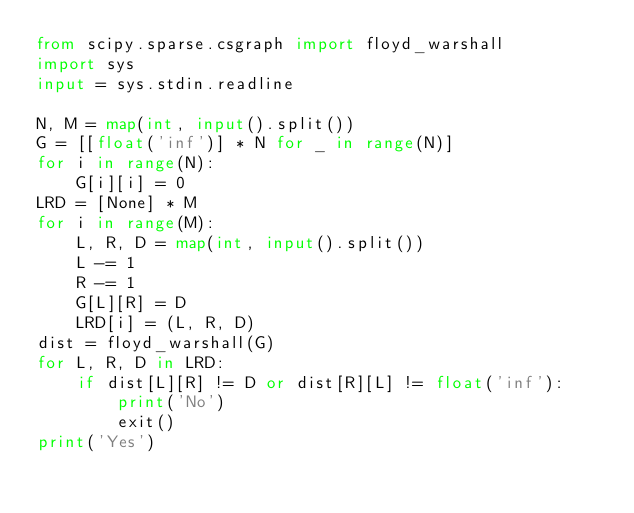<code> <loc_0><loc_0><loc_500><loc_500><_Python_>from scipy.sparse.csgraph import floyd_warshall
import sys
input = sys.stdin.readline

N, M = map(int, input().split())
G = [[float('inf')] * N for _ in range(N)]
for i in range(N):
    G[i][i] = 0
LRD = [None] * M
for i in range(M):
    L, R, D = map(int, input().split())
    L -= 1
    R -= 1
    G[L][R] = D
    LRD[i] = (L, R, D)
dist = floyd_warshall(G)
for L, R, D in LRD:
    if dist[L][R] != D or dist[R][L] != float('inf'):
        print('No')
        exit()
print('Yes')
</code> 